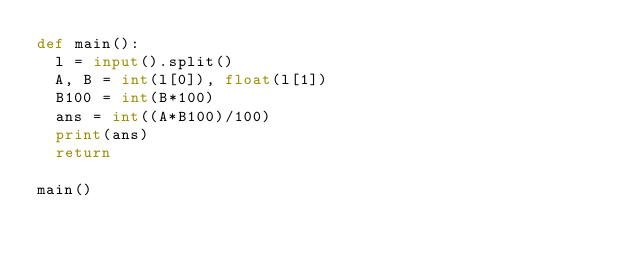Convert code to text. <code><loc_0><loc_0><loc_500><loc_500><_Python_>def main():
  l = input().split()
  A, B = int(l[0]), float(l[1])
  B100 = int(B*100)
  ans = int((A*B100)/100)
  print(ans)
  return

main()</code> 